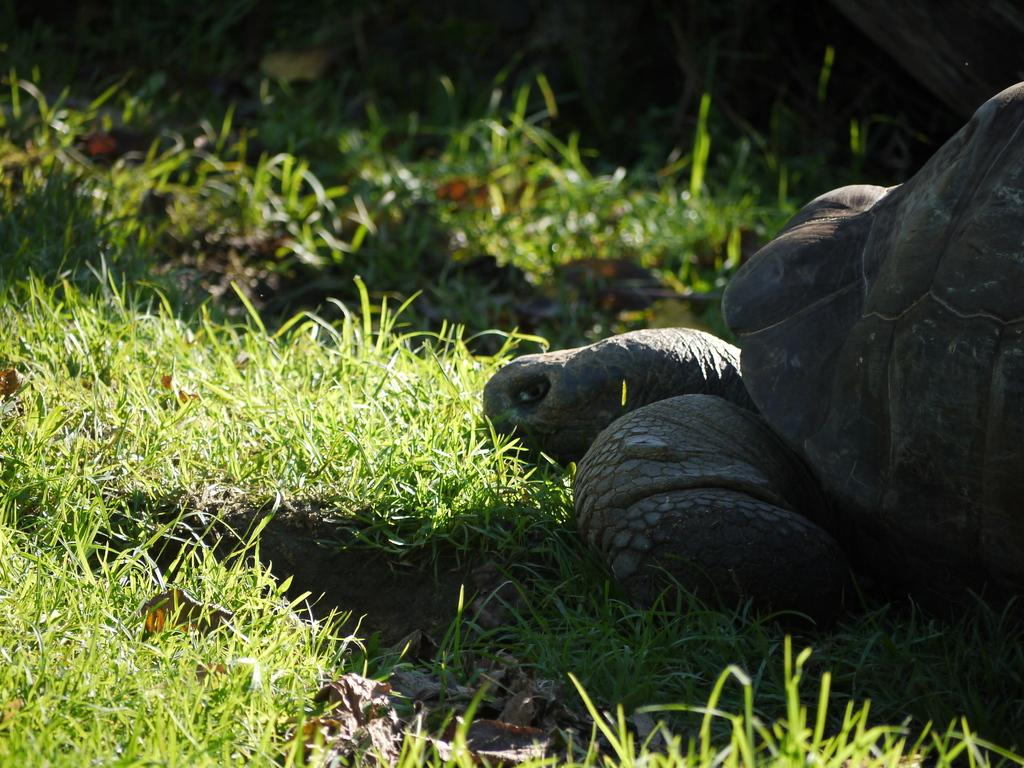What animal is on the ground in the image? There is a tortoise on the ground in the image. What type of vegetation can be seen in the image? There is grass visible in the image. What type of drink is the tortoise holding in the image? There is no drink present in the image; the tortoise is on the ground without any objects in its possession. 